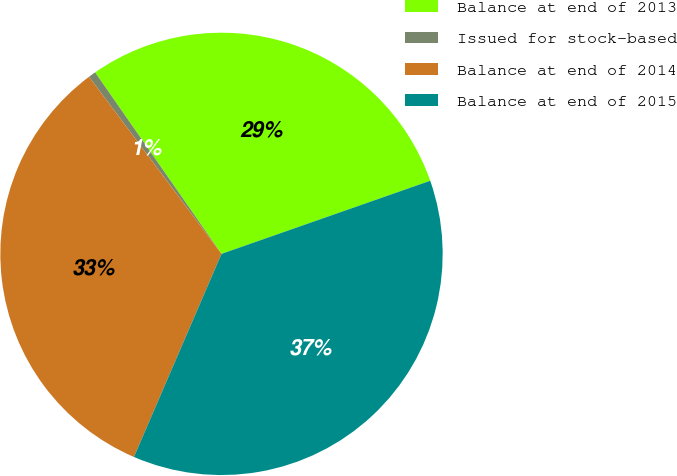Convert chart to OTSL. <chart><loc_0><loc_0><loc_500><loc_500><pie_chart><fcel>Balance at end of 2013<fcel>Issued for stock-based<fcel>Balance at end of 2014<fcel>Balance at end of 2015<nl><fcel>29.32%<fcel>0.54%<fcel>33.3%<fcel>36.84%<nl></chart> 